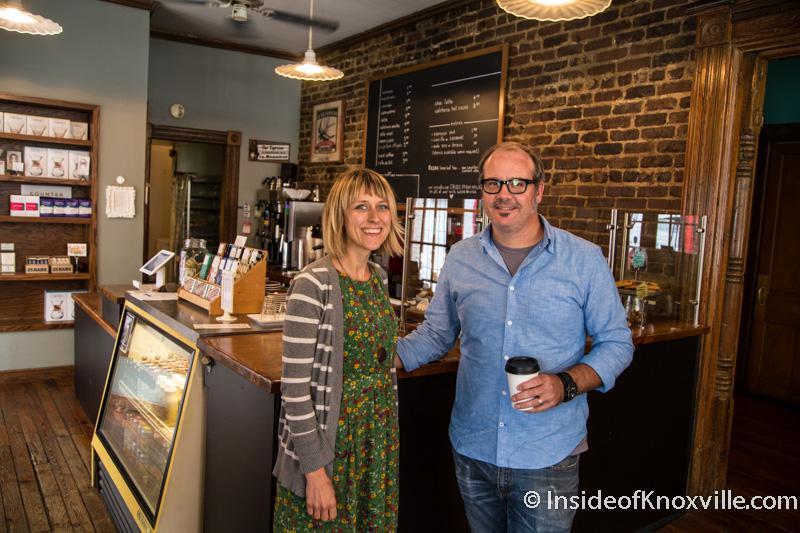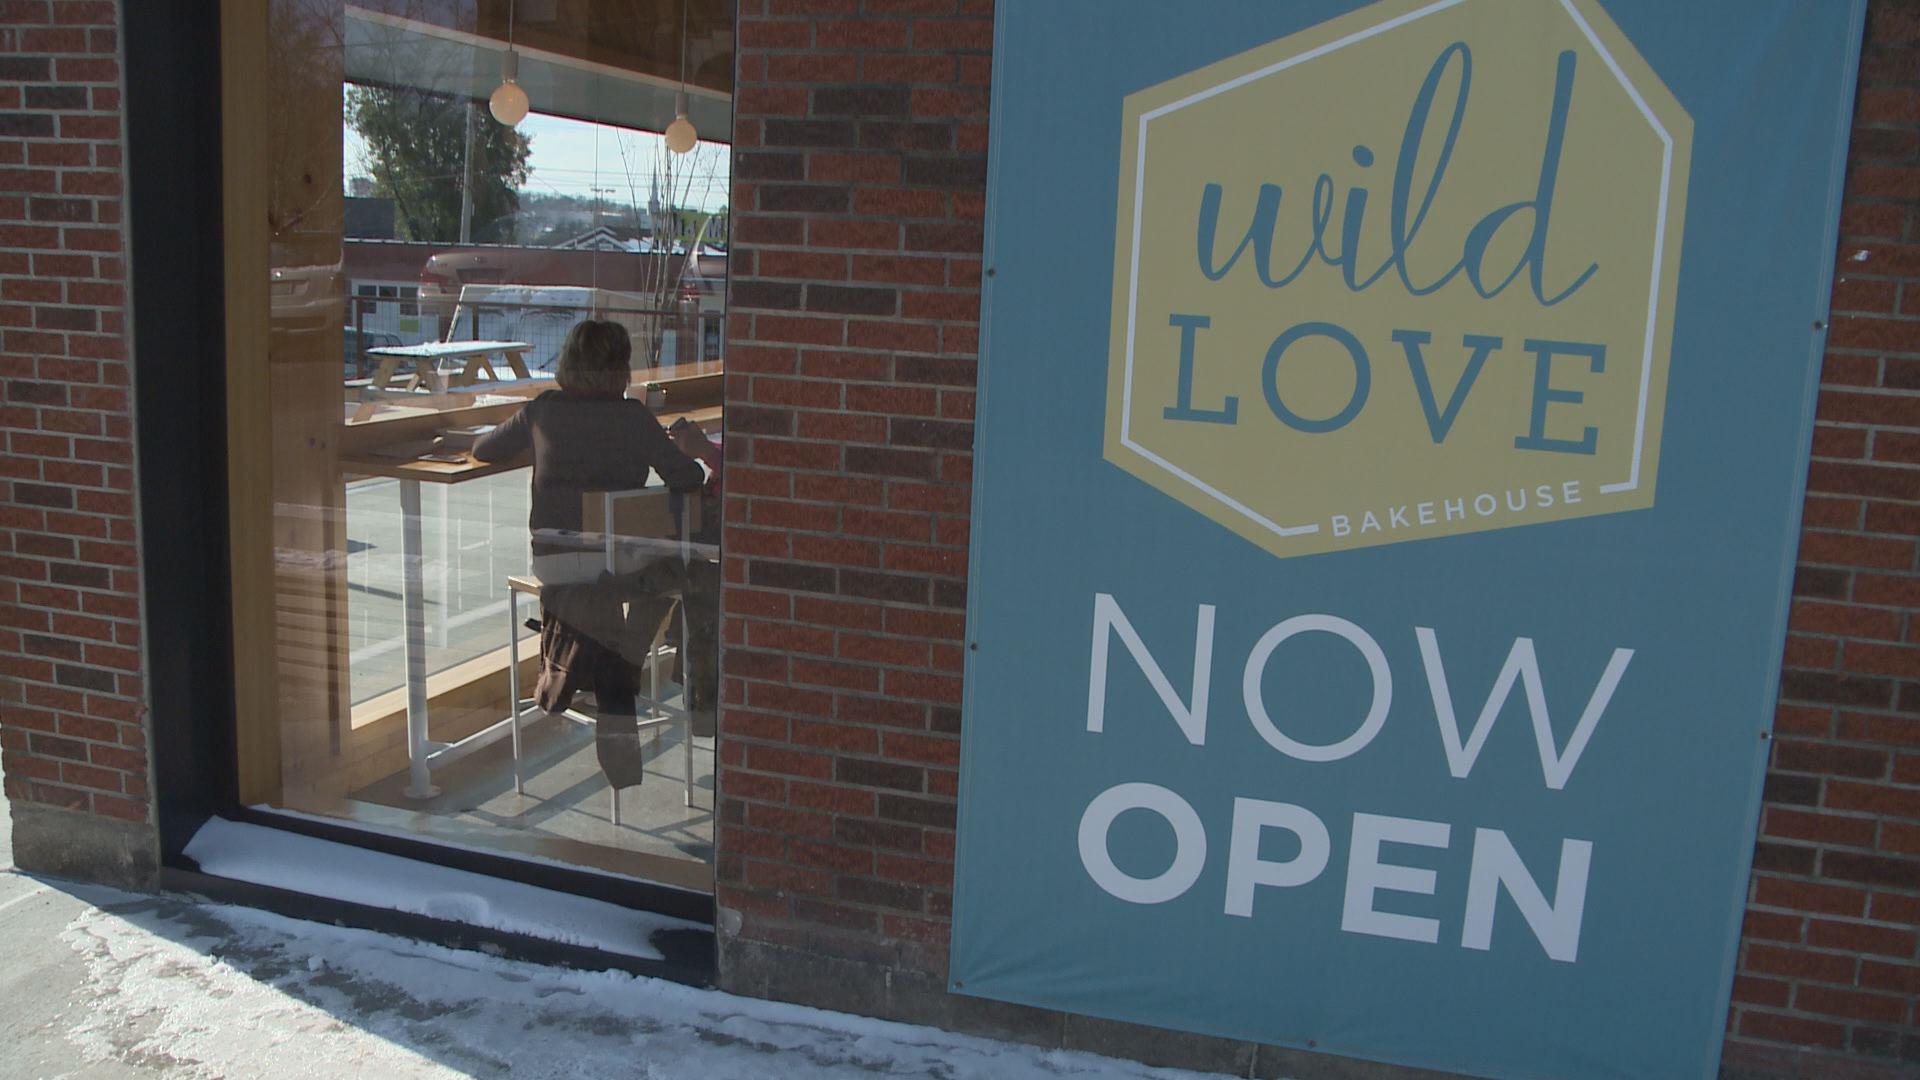The first image is the image on the left, the second image is the image on the right. For the images shown, is this caption "White lamps hang down over tables in a bakery in one of the images." true? Answer yes or no. No. The first image is the image on the left, the second image is the image on the right. For the images displayed, is the sentence "In at least one image you can see at least 5 adults sitting in  white and light brown chair with at least 5 visible  dropped white lights." factually correct? Answer yes or no. No. 